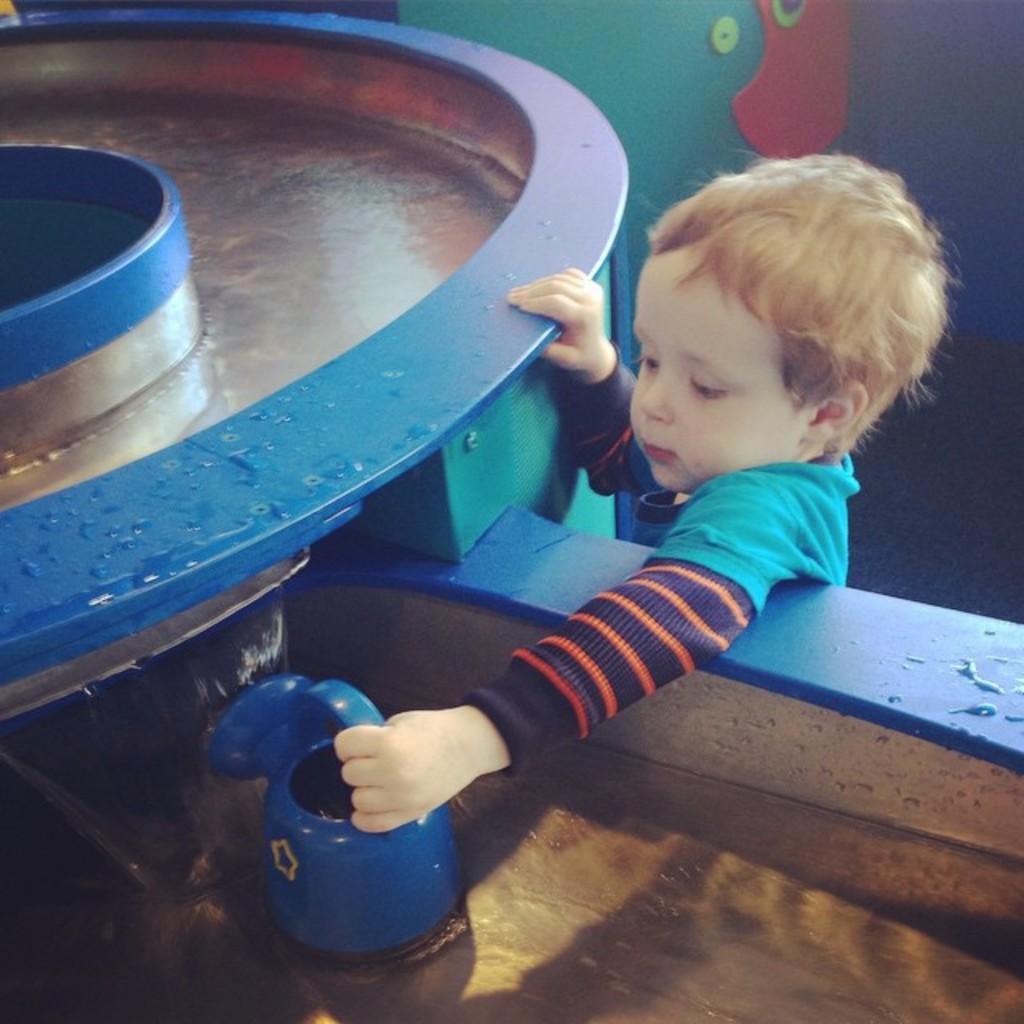Describe this image in one or two sentences. There is a child holding a blue color object. Also there is a blue color round object. In the back there is a wall. 